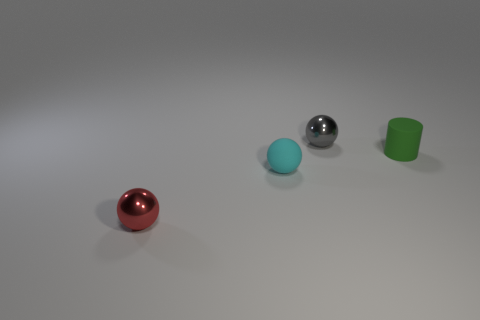Is the tiny sphere that is behind the tiny cyan thing made of the same material as the green cylinder?
Your answer should be compact. No. Are there an equal number of matte cylinders that are to the left of the red metallic ball and small green matte cylinders that are in front of the matte cylinder?
Provide a succinct answer. Yes. There is a gray metal sphere that is behind the rubber cylinder; what size is it?
Your answer should be compact. Small. Is there a cyan ball made of the same material as the tiny cyan thing?
Ensure brevity in your answer.  No. There is a metallic sphere behind the red metal sphere; is its color the same as the rubber ball?
Provide a short and direct response. No. Are there an equal number of spheres that are in front of the tiny rubber sphere and big cylinders?
Ensure brevity in your answer.  No. Does the green matte cylinder have the same size as the cyan object?
Offer a terse response. Yes. What size is the metal object that is on the left side of the small shiny ball that is to the right of the red object?
Give a very brief answer. Small. There is a sphere that is right of the tiny red metallic thing and in front of the tiny green object; how big is it?
Ensure brevity in your answer.  Small. What number of cyan balls have the same size as the gray object?
Offer a very short reply. 1. 